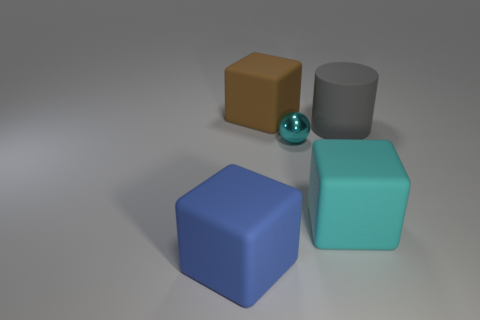There is a big thing that is the same color as the tiny shiny object; what is it made of?
Provide a succinct answer. Rubber. Is the number of large cyan rubber blocks that are right of the tiny metallic thing less than the number of red objects?
Offer a terse response. No. Do the big cube behind the matte cylinder and the large gray thing have the same material?
Your answer should be very brief. Yes. What is the color of the big cylinder that is the same material as the big blue object?
Offer a terse response. Gray. Is the number of large blue matte things that are behind the large cylinder less than the number of blue blocks in front of the blue object?
Your answer should be very brief. No. Is the color of the big rubber cube that is behind the tiny ball the same as the thing to the left of the brown rubber block?
Provide a short and direct response. No. Are there any small things that have the same material as the large gray object?
Provide a short and direct response. No. There is a object in front of the big cyan block in front of the big brown matte cube; what size is it?
Offer a very short reply. Large. Are there more tiny cyan things than large red metal cylinders?
Keep it short and to the point. Yes. Does the cube behind the gray matte cylinder have the same size as the cyan metallic ball?
Keep it short and to the point. No. 